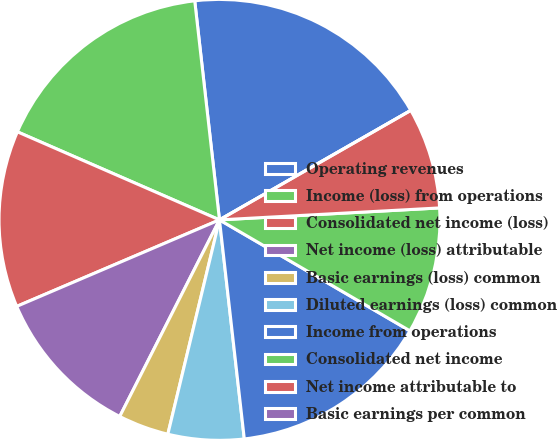<chart> <loc_0><loc_0><loc_500><loc_500><pie_chart><fcel>Operating revenues<fcel>Income (loss) from operations<fcel>Consolidated net income (loss)<fcel>Net income (loss) attributable<fcel>Basic earnings (loss) common<fcel>Diluted earnings (loss) common<fcel>Income from operations<fcel>Consolidated net income<fcel>Net income attributable to<fcel>Basic earnings per common<nl><fcel>18.52%<fcel>16.67%<fcel>12.96%<fcel>11.11%<fcel>3.71%<fcel>5.56%<fcel>14.81%<fcel>9.26%<fcel>7.41%<fcel>0.0%<nl></chart> 